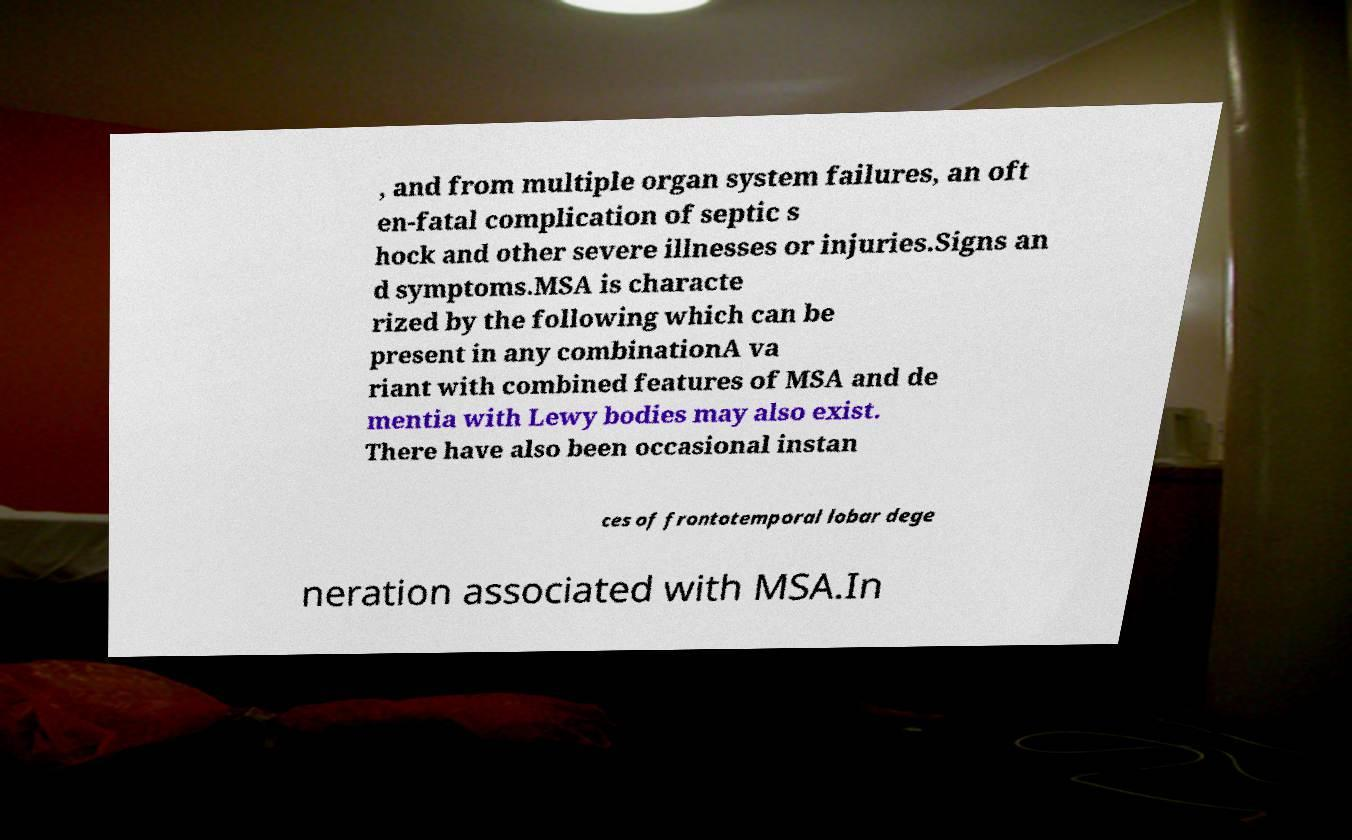Please identify and transcribe the text found in this image. , and from multiple organ system failures, an oft en-fatal complication of septic s hock and other severe illnesses or injuries.Signs an d symptoms.MSA is characte rized by the following which can be present in any combinationA va riant with combined features of MSA and de mentia with Lewy bodies may also exist. There have also been occasional instan ces of frontotemporal lobar dege neration associated with MSA.In 